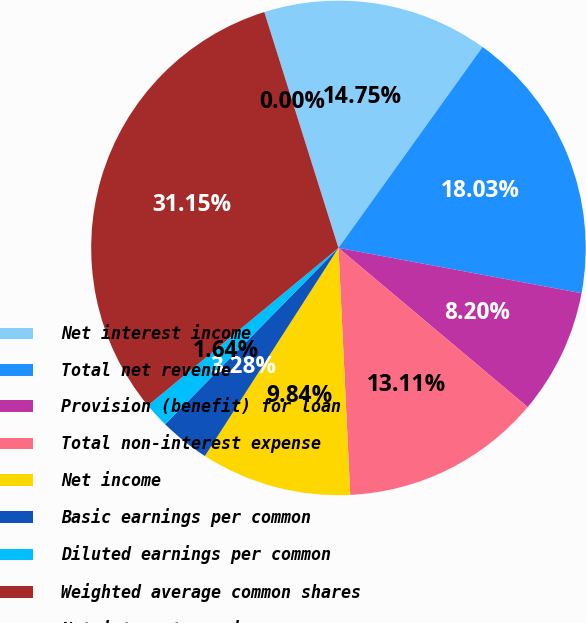Convert chart. <chart><loc_0><loc_0><loc_500><loc_500><pie_chart><fcel>Net interest income<fcel>Total net revenue<fcel>Provision (benefit) for loan<fcel>Total non-interest expense<fcel>Net income<fcel>Basic earnings per common<fcel>Diluted earnings per common<fcel>Weighted average common shares<fcel>Net interest margin<nl><fcel>14.75%<fcel>18.03%<fcel>8.2%<fcel>13.11%<fcel>9.84%<fcel>3.28%<fcel>1.64%<fcel>31.15%<fcel>0.0%<nl></chart> 